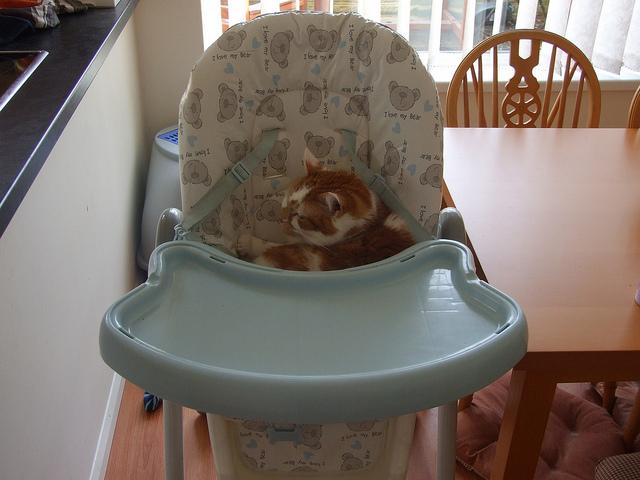Is there a stuffed animal in this picture?
Quick response, please. No. Is the chair for the cat?
Concise answer only. No. What is the cat sitting in?
Give a very brief answer. High chair. 